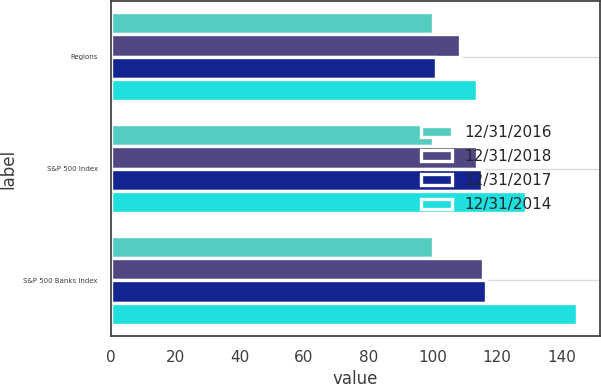<chart> <loc_0><loc_0><loc_500><loc_500><stacked_bar_chart><ecel><fcel>Regions<fcel>S&P 500 Index<fcel>S&P 500 Banks Index<nl><fcel>12/31/2016<fcel>100<fcel>100<fcel>100<nl><fcel>12/31/2018<fcel>108.63<fcel>113.68<fcel>115.51<nl><fcel>12/31/2017<fcel>101.11<fcel>115.24<fcel>116.49<nl><fcel>12/31/2014<fcel>113.68<fcel>129.02<fcel>144.81<nl></chart> 